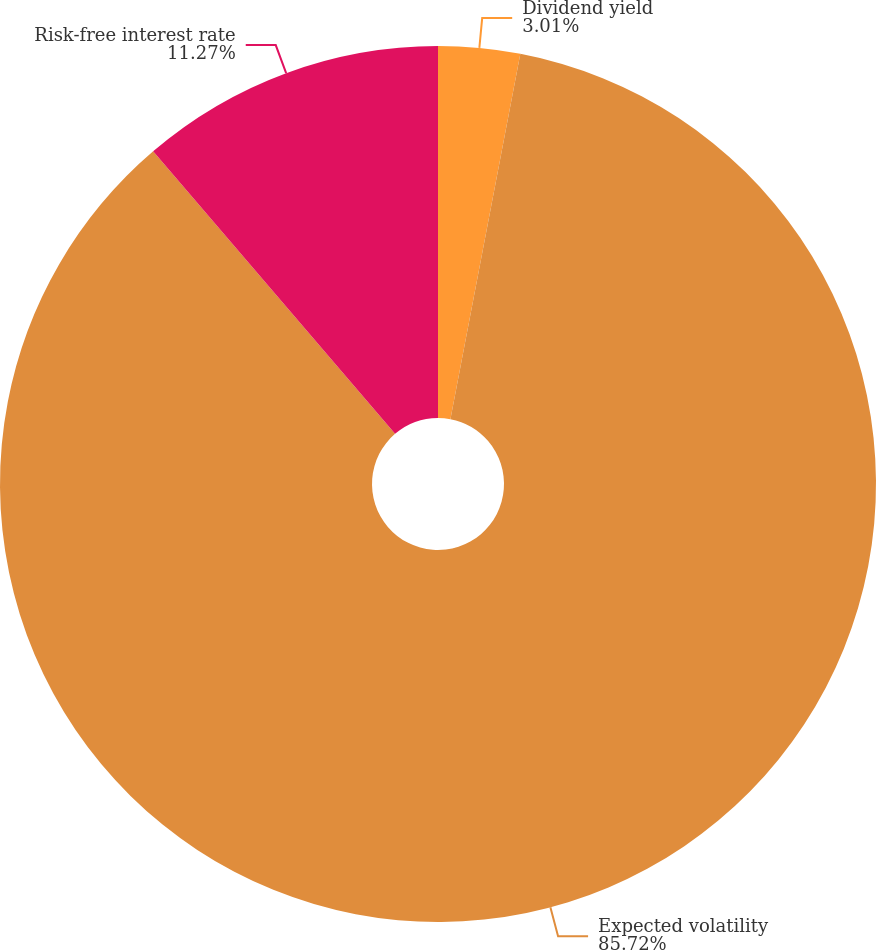<chart> <loc_0><loc_0><loc_500><loc_500><pie_chart><fcel>Dividend yield<fcel>Expected volatility<fcel>Risk-free interest rate<nl><fcel>3.01%<fcel>85.72%<fcel>11.27%<nl></chart> 